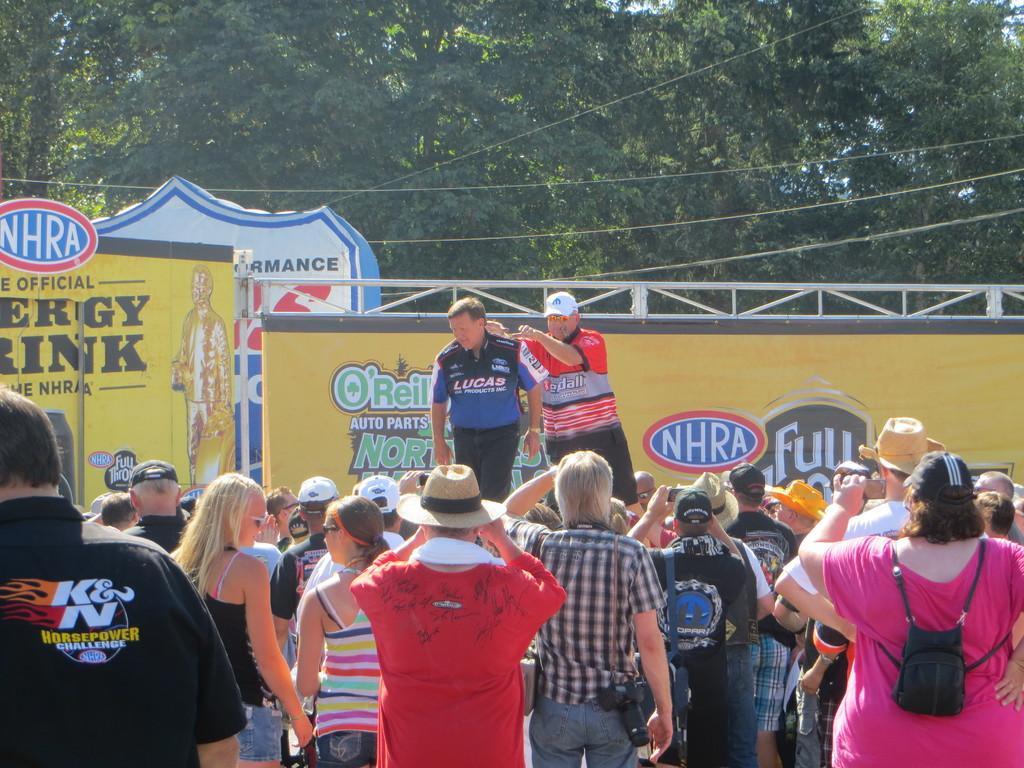Please provide a concise description of this image. In this picture I can see so many people are standing, among them two persons are standing on the stage, behind there are some banners and trees. 